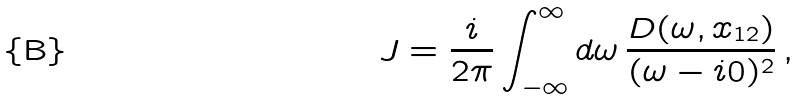Convert formula to latex. <formula><loc_0><loc_0><loc_500><loc_500>J = \frac { i } { 2 \pi } \int _ { - \infty } ^ { \infty } d \omega \, \frac { D ( \omega , x _ { 1 2 } ) } { ( \omega - i 0 ) ^ { 2 } } \, ,</formula> 